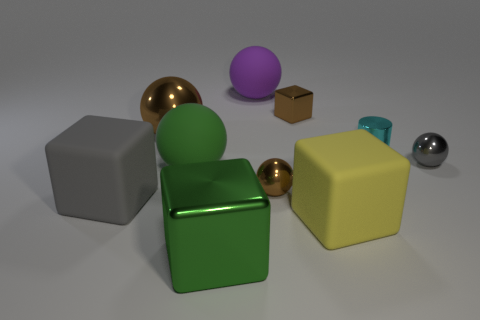There is a purple thing behind the tiny gray shiny ball; does it have the same shape as the large metallic thing that is behind the yellow object?
Keep it short and to the point. Yes. The cyan object has what size?
Keep it short and to the point. Small. The brown sphere to the left of the green object that is behind the large metal object that is in front of the tiny cyan metallic cylinder is made of what material?
Provide a succinct answer. Metal. What number of other things are the same color as the big shiny block?
Keep it short and to the point. 1. How many cyan objects are either cylinders or tiny metallic things?
Your answer should be compact. 1. There is a sphere in front of the big green matte thing; what is its material?
Make the answer very short. Metal. Does the cube that is in front of the yellow rubber cube have the same material as the green ball?
Make the answer very short. No. What is the shape of the purple object?
Offer a very short reply. Sphere. There is a metal ball left of the large matte object that is behind the shiny cylinder; how many small brown metallic spheres are behind it?
Ensure brevity in your answer.  0. How many other things are the same material as the large brown sphere?
Make the answer very short. 5. 